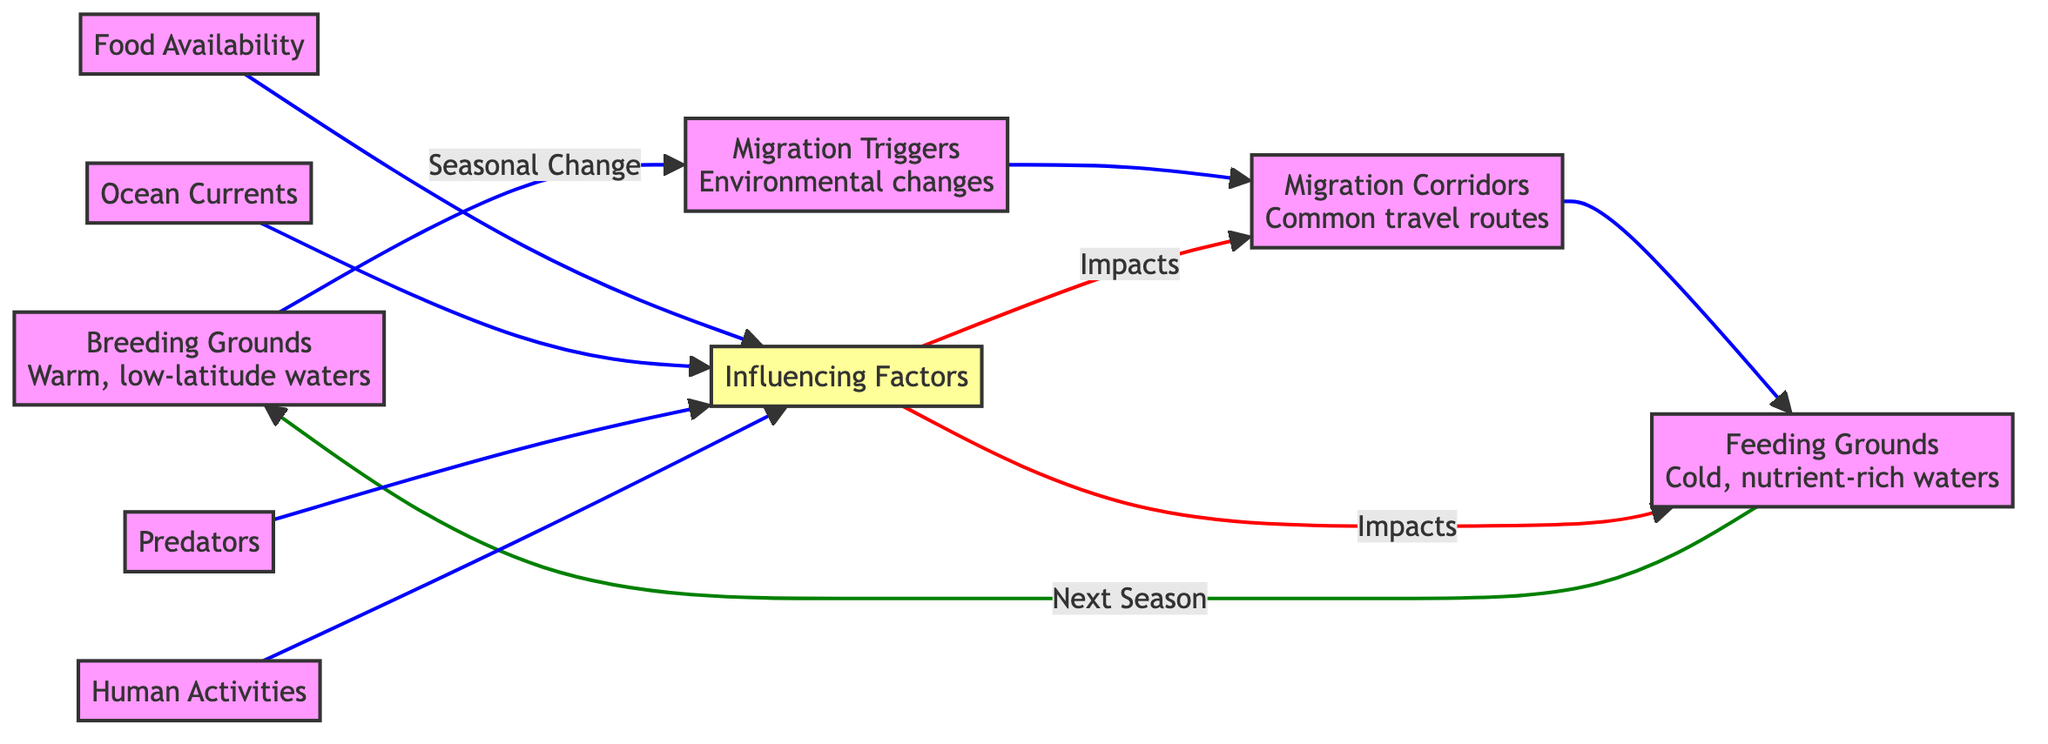What are the two types of grounds mentioned in the diagram? The diagram lists "Breeding Grounds" and "Feeding Grounds" as two types of grounds. These are defined in the flowchart, with Breeding Grounds located at the start and Feeding Grounds before the returning to Breeding Grounds.
Answer: Breeding Grounds, Feeding Grounds What prompts the whales to migrate according to the diagram? The diagram specifies "Migration Triggers" as the element that prompts migration. There is a directional connection from "Breeding Grounds" to "Migration Triggers," indicating that seasonal changes in the breeding areas lead to migration.
Answer: Migration Triggers Which node follows the "Migration Triggers" in the flowchart? After "Migration Triggers," the next node is "Migration Corridors." The flowchart layout shows the direct connection from B to C.
Answer: Migration Corridors How many influencing factors are listed in the diagram? The diagram includes four influencing factors: Food Availability, Ocean Currents, Predators, and Human Activities. By counting these factors connected to the influencing factors node E, we find the total.
Answer: Four What relationship is shown between "Influencing Factors" and "Feeding Grounds"? The diagram indicates that "Influencing Factors" impacts "Feeding Grounds." The flow from E to D demonstrates that the factors listed influence the feeding areas of the whales.
Answer: Impacts Which migration pathway is highlighted for moving from breeding to feeding areas? The pathway highlighted in the flowchart from "Breeding Grounds" to "Feeding Grounds" is through "Migration Corridors." The connections show the sequence of migration stages from breeding to feeding.
Answer: Migration Corridors What describes the waters where whales breed and give birth? The waters where whales breed and give birth are described as "Warm, low-latitude waters." This description is provided directly in the information next to the "Breeding Grounds" node.
Answer: Warm, low-latitude waters Which factor could hinder a whale's migration according to the flowchart? The flowchart includes "Ocean Currents," which describes strong currents that can hinder migration. This is evident as it directly connects with the "Influencing Factors" node and indicates an impact on migration.
Answer: Ocean Currents How does human activity influence whale migration? The “Human Activities” factor is listed under “Influencing Factors” in the flowchart. It specifically describes the impact of shipping lanes, fishing nets, and pollution, illustrating a negative influence on whale migration patterns.
Answer: Impact of shipping lanes, fishing nets, and pollution 